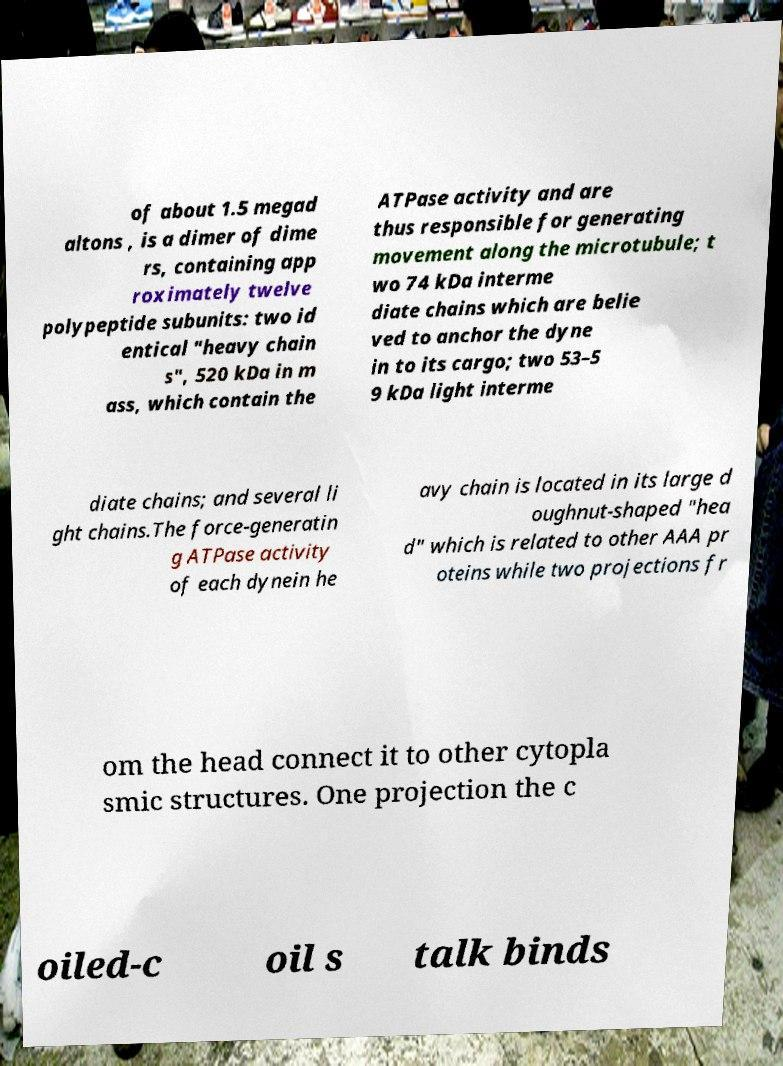Please identify and transcribe the text found in this image. of about 1.5 megad altons , is a dimer of dime rs, containing app roximately twelve polypeptide subunits: two id entical "heavy chain s", 520 kDa in m ass, which contain the ATPase activity and are thus responsible for generating movement along the microtubule; t wo 74 kDa interme diate chains which are belie ved to anchor the dyne in to its cargo; two 53–5 9 kDa light interme diate chains; and several li ght chains.The force-generatin g ATPase activity of each dynein he avy chain is located in its large d oughnut-shaped "hea d" which is related to other AAA pr oteins while two projections fr om the head connect it to other cytopla smic structures. One projection the c oiled-c oil s talk binds 